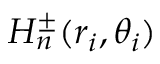<formula> <loc_0><loc_0><loc_500><loc_500>H _ { n } ^ { \pm } ( r _ { i } , \theta _ { i } )</formula> 